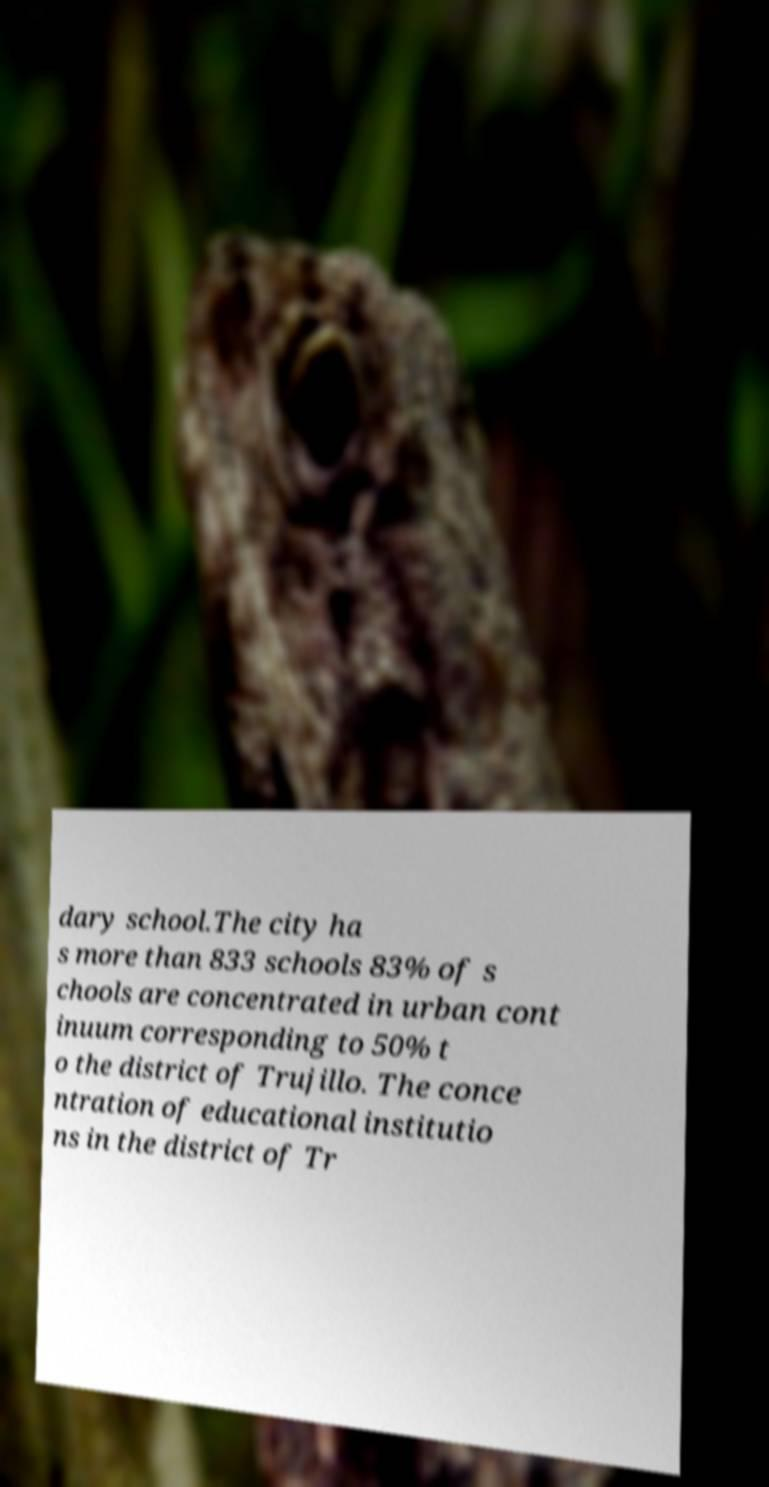Could you assist in decoding the text presented in this image and type it out clearly? dary school.The city ha s more than 833 schools 83% of s chools are concentrated in urban cont inuum corresponding to 50% t o the district of Trujillo. The conce ntration of educational institutio ns in the district of Tr 